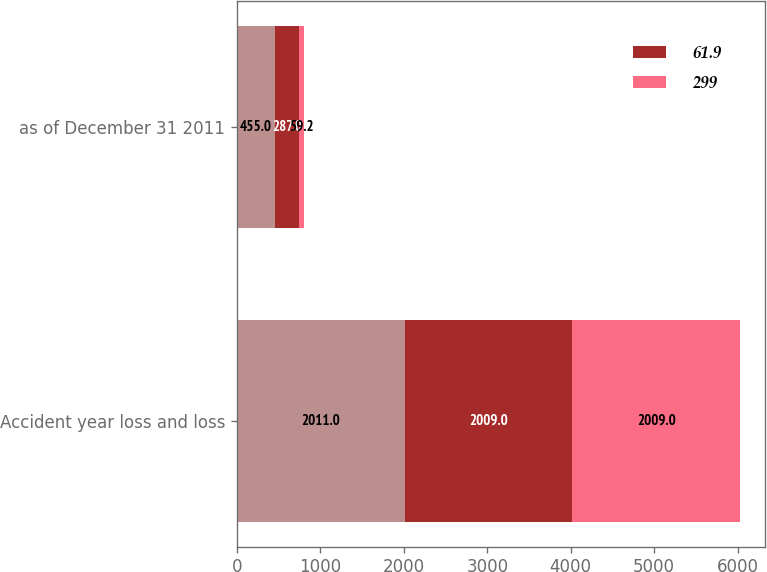Convert chart to OTSL. <chart><loc_0><loc_0><loc_500><loc_500><stacked_bar_chart><ecel><fcel>Accident year loss and loss<fcel>as of December 31 2011<nl><fcel>nan<fcel>2011<fcel>455<nl><fcel>61.9<fcel>2009<fcel>287<nl><fcel>299<fcel>2009<fcel>59.2<nl></chart> 